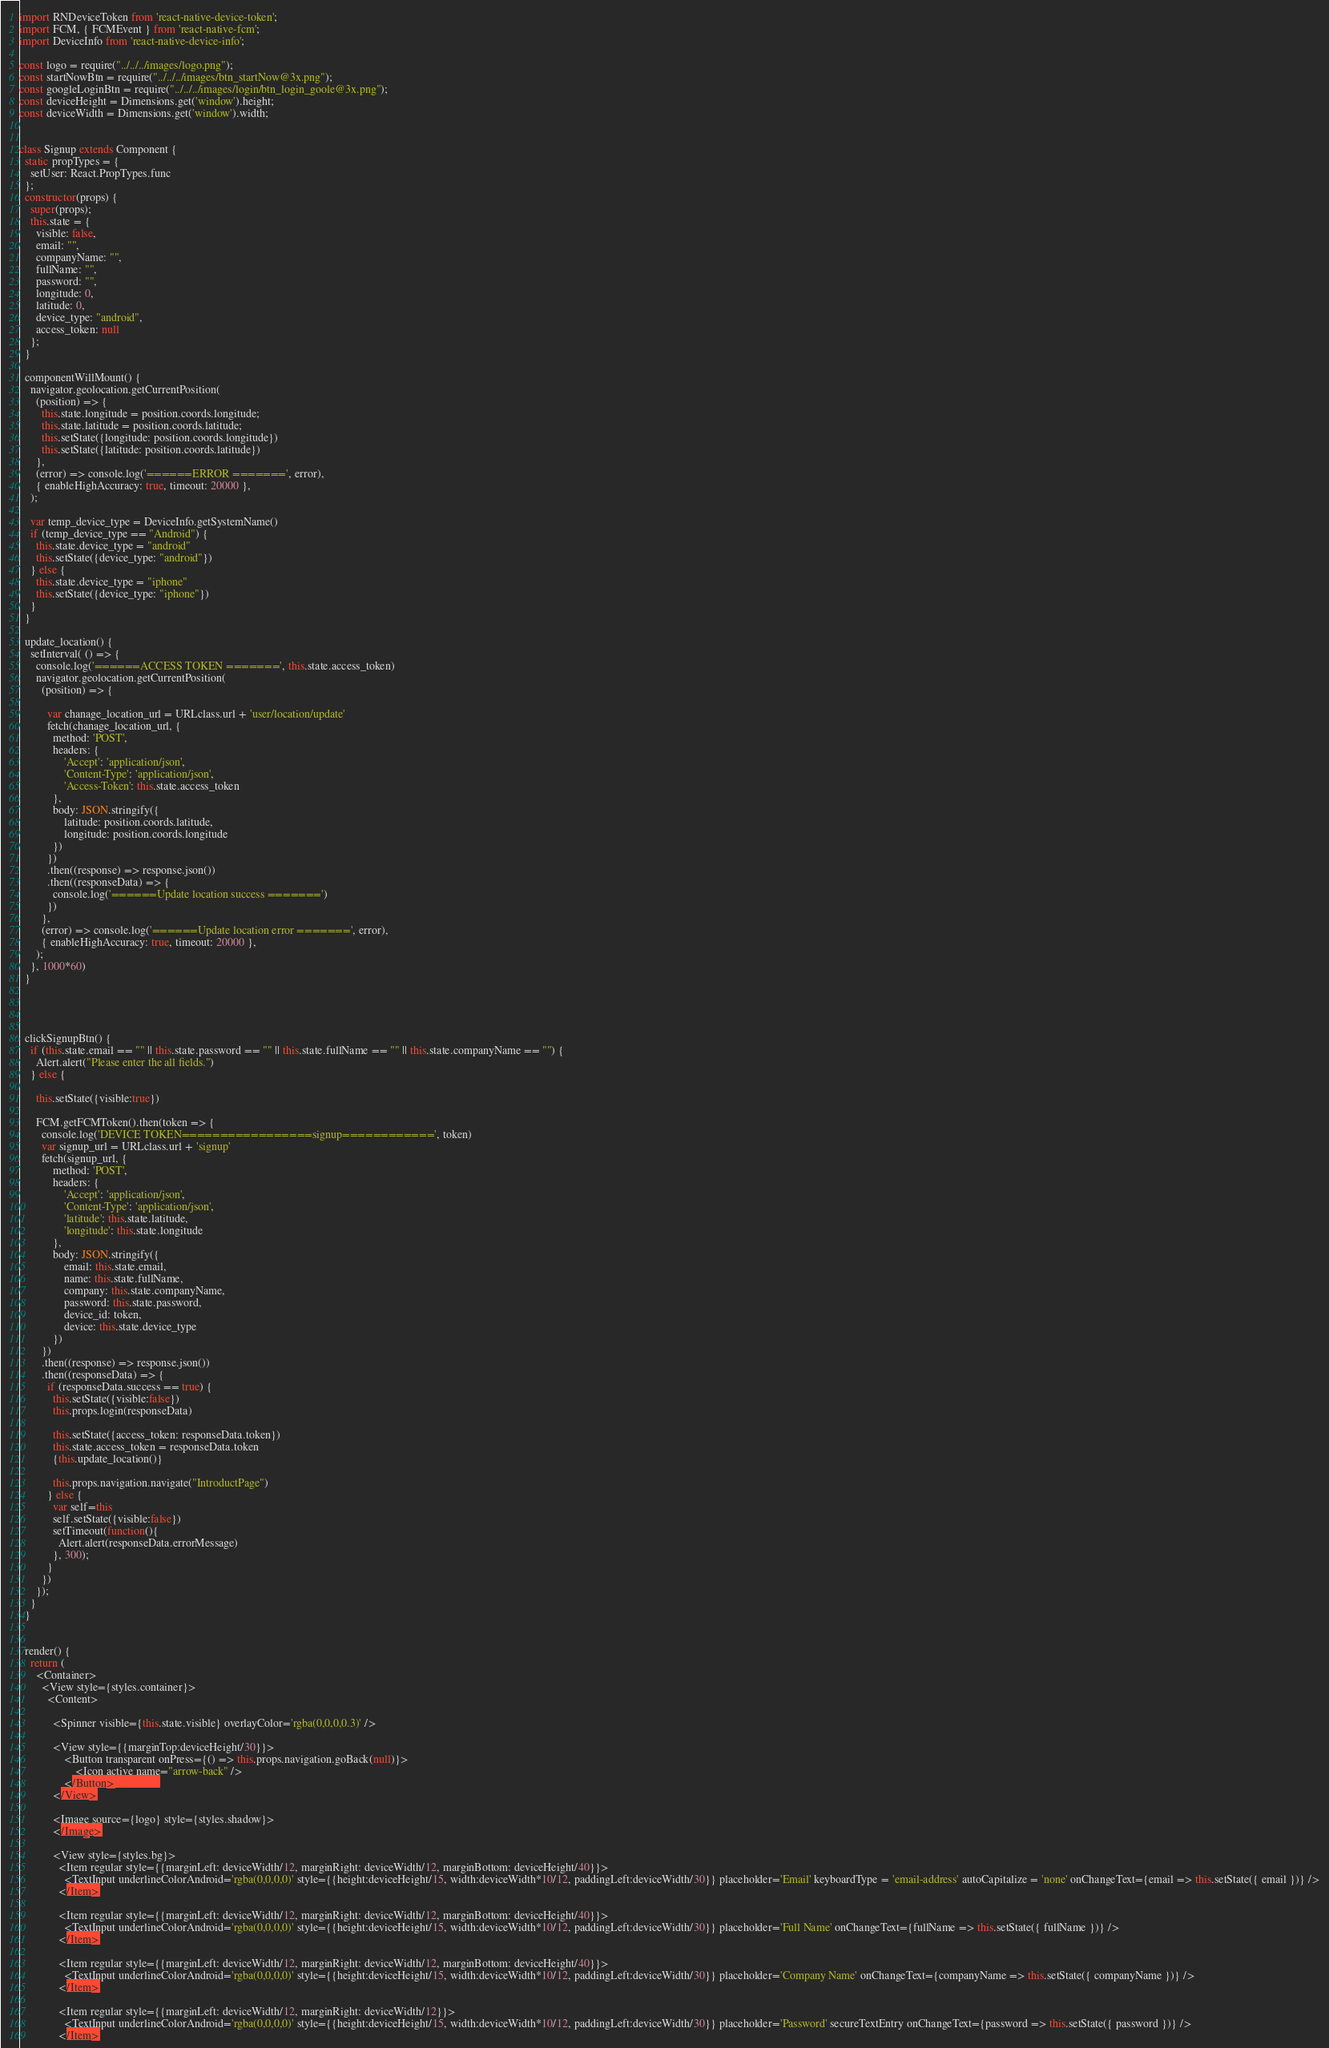Convert code to text. <code><loc_0><loc_0><loc_500><loc_500><_JavaScript_>import RNDeviceToken from 'react-native-device-token';
import FCM, { FCMEvent } from 'react-native-fcm';
import DeviceInfo from 'react-native-device-info';

const logo = require("../../../images/logo.png");
const startNowBtn = require("../../../images/btn_startNow@3x.png");
const googleLoginBtn = require("../../../images/login/btn_login_goole@3x.png");
const deviceHeight = Dimensions.get('window').height;
const deviceWidth = Dimensions.get('window').width;


class Signup extends Component {
  static propTypes = {
    setUser: React.PropTypes.func
  };
  constructor(props) {
    super(props);
    this.state = {
      visible: false,
      email: "",
      companyName: "",
      fullName: "",
      password: "",
      longitude: 0,
      latitude: 0,
      device_type: "android",
      access_token: null
    };
  }

  componentWillMount() {
    navigator.geolocation.getCurrentPosition(
      (position) => {
        this.state.longitude = position.coords.longitude;
        this.state.latitude = position.coords.latitude;
        this.setState({longitude: position.coords.longitude})
        this.setState({latitude: position.coords.latitude})
      },
      (error) => console.log('======ERROR =======', error),
      { enableHighAccuracy: true, timeout: 20000 },
    );

    var temp_device_type = DeviceInfo.getSystemName()
    if (temp_device_type == "Android") {
      this.state.device_type = "android"
      this.setState({device_type: "android"})
    } else {
      this.state.device_type = "iphone"
      this.setState({device_type: "iphone"})
    }
  }

  update_location() {
    setInterval( () => {
      console.log('======ACCESS TOKEN =======', this.state.access_token)
      navigator.geolocation.getCurrentPosition(
        (position) => {

          var chanage_location_url = URLclass.url + 'user/location/update'
          fetch(chanage_location_url, {
            method: 'POST',
            headers: {
                'Accept': 'application/json',
                'Content-Type': 'application/json',
                'Access-Token': this.state.access_token
            },
            body: JSON.stringify({
                latitude: position.coords.latitude,
                longitude: position.coords.longitude
            })
          })
          .then((response) => response.json())
          .then((responseData) => {
            console.log('======Update location success =======')
          })
        },
        (error) => console.log('======Update location error =======', error),
        { enableHighAccuracy: true, timeout: 20000 },
      );
    }, 1000*60)
  }



  
  clickSignupBtn() {
    if (this.state.email == "" || this.state.password == "" || this.state.fullName == "" || this.state.companyName == "") {
      Alert.alert("Please enter the all fields.")
    } else {

      this.setState({visible:true})

      FCM.getFCMToken().then(token => {
        console.log('DEVICE TOKEN=================signup============', token)
        var signup_url = URLclass.url + 'signup'
        fetch(signup_url, {
            method: 'POST',
            headers: {
                'Accept': 'application/json',
                'Content-Type': 'application/json',
                'latitude': this.state.latitude,
                'longitude': this.state.longitude
            },
            body: JSON.stringify({
                email: this.state.email,
                name: this.state.fullName,
                company: this.state.companyName,
                password: this.state.password,
                device_id: token,
                device: this.state.device_type
            })
        })
        .then((response) => response.json())
        .then((responseData) => {
          if (responseData.success == true) {
            this.setState({visible:false})
            this.props.login(responseData)

            this.setState({access_token: responseData.token})
            this.state.access_token = responseData.token
            {this.update_location()}

            this.props.navigation.navigate("IntroductPage")
          } else {
            var self=this
            self.setState({visible:false})
            setTimeout(function(){
              Alert.alert(responseData.errorMessage)
            }, 300);
          }
        })
      });
    }
  }


  render() {
    return (
      <Container>
        <View style={styles.container}>
          <Content>
          
            <Spinner visible={this.state.visible} overlayColor='rgba(0,0,0,0.3)' />

            <View style={{marginTop:deviceHeight/30}}>
                <Button transparent onPress={() => this.props.navigation.goBack(null)}>
                    <Icon active name="arrow-back" />
                </Button>              
            </View>

            <Image source={logo} style={styles.shadow}>
            </Image>

            <View style={styles.bg}>
              <Item regular style={{marginLeft: deviceWidth/12, marginRight: deviceWidth/12, marginBottom: deviceHeight/40}}>
                <TextInput underlineColorAndroid='rgba(0,0,0,0)' style={{height:deviceHeight/15, width:deviceWidth*10/12, paddingLeft:deviceWidth/30}} placeholder='Email' keyboardType = 'email-address' autoCapitalize = 'none' onChangeText={email => this.setState({ email })} />
              </Item>
              
              <Item regular style={{marginLeft: deviceWidth/12, marginRight: deviceWidth/12, marginBottom: deviceHeight/40}}>
                <TextInput underlineColorAndroid='rgba(0,0,0,0)' style={{height:deviceHeight/15, width:deviceWidth*10/12, paddingLeft:deviceWidth/30}} placeholder='Full Name' onChangeText={fullName => this.setState({ fullName })} />
              </Item>

              <Item regular style={{marginLeft: deviceWidth/12, marginRight: deviceWidth/12, marginBottom: deviceHeight/40}}>
                <TextInput underlineColorAndroid='rgba(0,0,0,0)' style={{height:deviceHeight/15, width:deviceWidth*10/12, paddingLeft:deviceWidth/30}} placeholder='Company Name' onChangeText={companyName => this.setState({ companyName })} />
              </Item>

              <Item regular style={{marginLeft: deviceWidth/12, marginRight: deviceWidth/12}}>
                <TextInput underlineColorAndroid='rgba(0,0,0,0)' style={{height:deviceHeight/15, width:deviceWidth*10/12, paddingLeft:deviceWidth/30}} placeholder='Password' secureTextEntry onChangeText={password => this.setState({ password })} />
              </Item>
</code> 